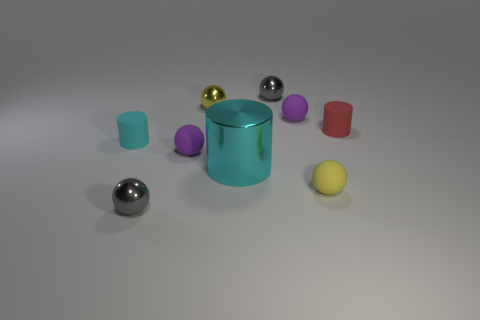Subtract all yellow spheres. How many were subtracted if there are1yellow spheres left? 1 Subtract all purple spheres. How many spheres are left? 4 Subtract all yellow metallic spheres. How many spheres are left? 5 Subtract 2 spheres. How many spheres are left? 4 Subtract all cyan spheres. Subtract all green cylinders. How many spheres are left? 6 Add 1 large cyan metal cylinders. How many objects exist? 10 Subtract all cylinders. How many objects are left? 6 Add 8 yellow metal things. How many yellow metal things exist? 9 Subtract 0 blue spheres. How many objects are left? 9 Subtract all red matte cylinders. Subtract all rubber balls. How many objects are left? 5 